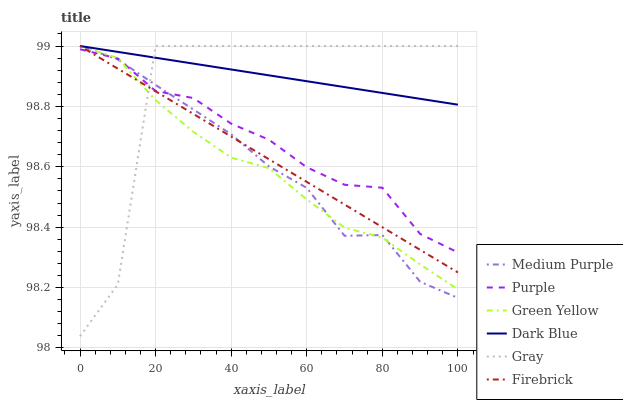Does Green Yellow have the minimum area under the curve?
Answer yes or no. Yes. Does Dark Blue have the maximum area under the curve?
Answer yes or no. Yes. Does Purple have the minimum area under the curve?
Answer yes or no. No. Does Purple have the maximum area under the curve?
Answer yes or no. No. Is Firebrick the smoothest?
Answer yes or no. Yes. Is Gray the roughest?
Answer yes or no. Yes. Is Purple the smoothest?
Answer yes or no. No. Is Purple the roughest?
Answer yes or no. No. Does Purple have the lowest value?
Answer yes or no. No. Does Purple have the highest value?
Answer yes or no. No. Is Purple less than Dark Blue?
Answer yes or no. Yes. Is Dark Blue greater than Purple?
Answer yes or no. Yes. Does Purple intersect Dark Blue?
Answer yes or no. No. 